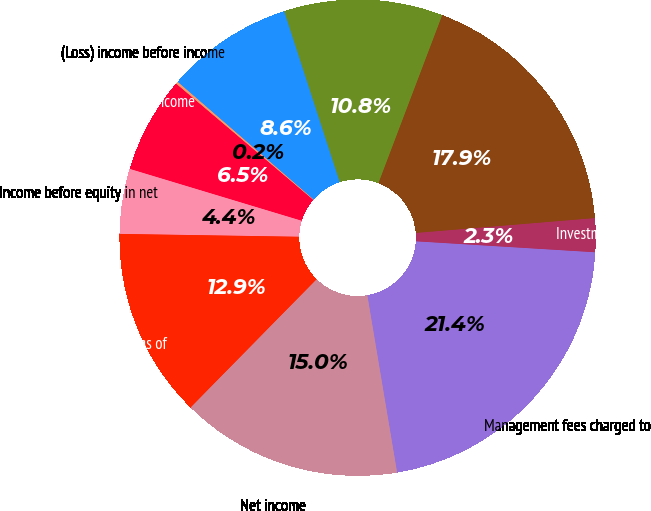Convert chart to OTSL. <chart><loc_0><loc_0><loc_500><loc_500><pie_chart><fcel>Management fees charged to<fcel>Investment income and other<fcel>Selling general and<fcel>Depreciation<fcel>Interest<fcel>(Loss) income before income<fcel>(Benefit) provision for income<fcel>Income before equity in net<fcel>Equity in net earnings of<fcel>Net income<nl><fcel>21.38%<fcel>2.29%<fcel>17.91%<fcel>10.77%<fcel>8.65%<fcel>0.16%<fcel>6.53%<fcel>4.41%<fcel>12.89%<fcel>15.01%<nl></chart> 